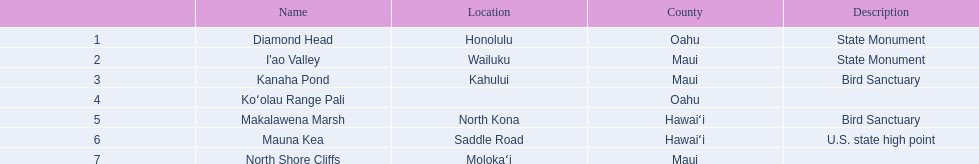What are the national natural landmarks in hawaii? Diamond Head, I'ao Valley, Kanaha Pond, Koʻolau Range Pali, Makalawena Marsh, Mauna Kea, North Shore Cliffs. Which of theses are in hawa'i county? Makalawena Marsh, Mauna Kea. Of these which has a bird sanctuary? Makalawena Marsh. 